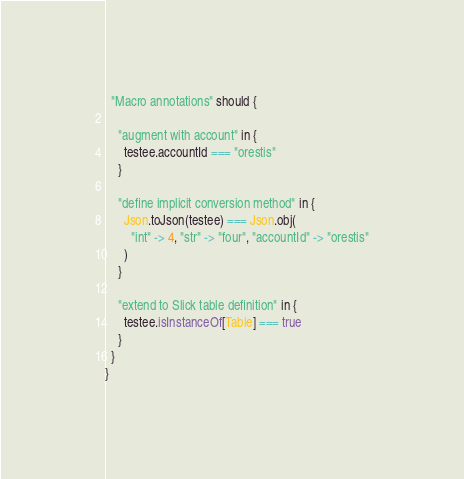<code> <loc_0><loc_0><loc_500><loc_500><_Scala_>  "Macro annotations" should {

    "augment with account" in {
      testee.accountId === "orestis"
    }

    "define implicit conversion method" in {
      Json.toJson(testee) === Json.obj(
        "int" -> 4, "str" -> "four", "accountId" -> "orestis"
      )
    }

    "extend to Slick table definition" in {
      testee.isInstanceOf[Table] === true
    }
  }
}
</code> 